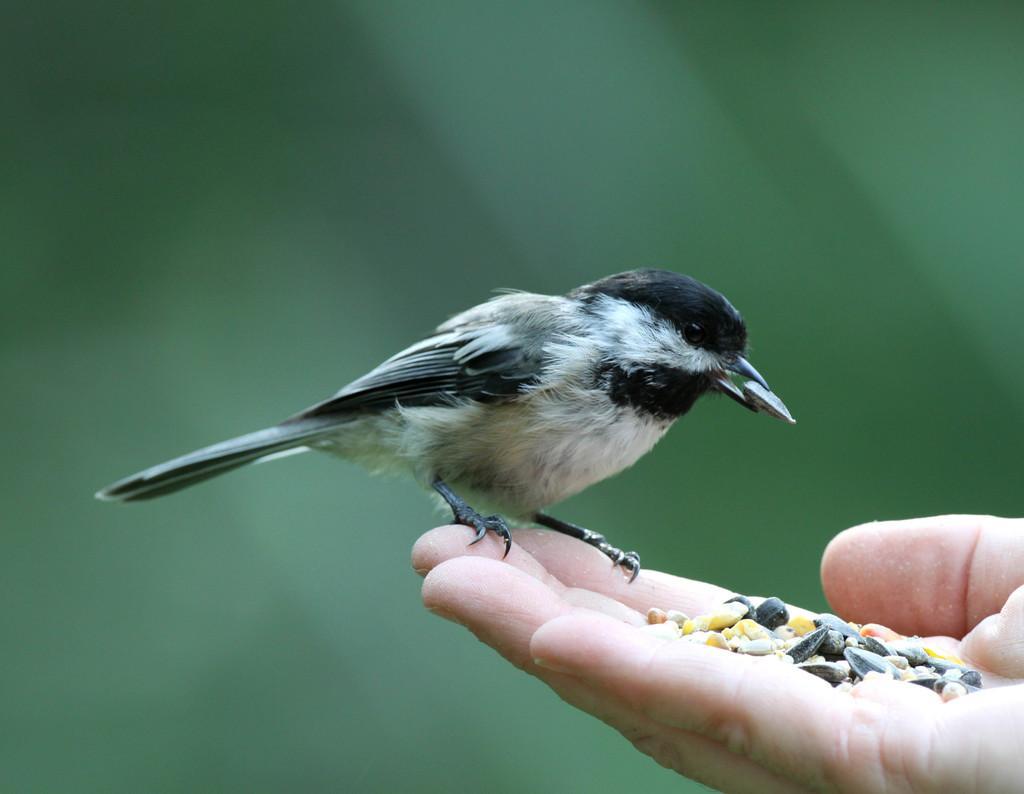Please provide a concise description of this image. In the image there is a bird standing on hand with grains in it and the background is blurry. 